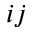<formula> <loc_0><loc_0><loc_500><loc_500>i j</formula> 